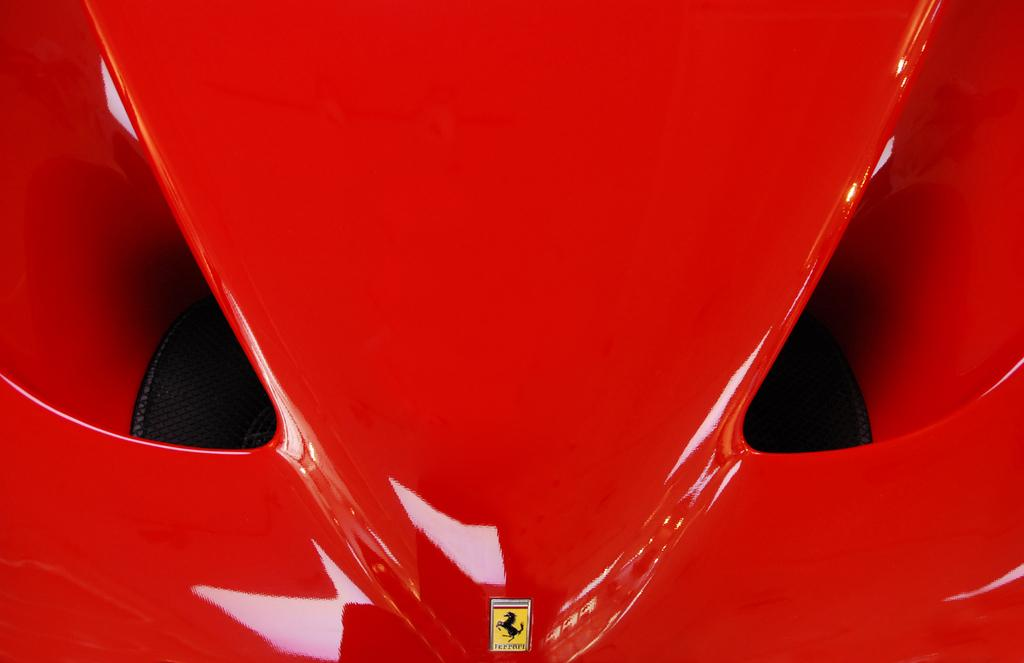What color is the car in the picture? The car in the picture is red. How close is the view of the car in the picture? The car is shown in a closer view. Can you identify any specific details on the car? Yes, there is a logo visible on the car. How much honey is dripping from the car in the picture? There is no honey present in the image; it features a red car with a visible logo. 